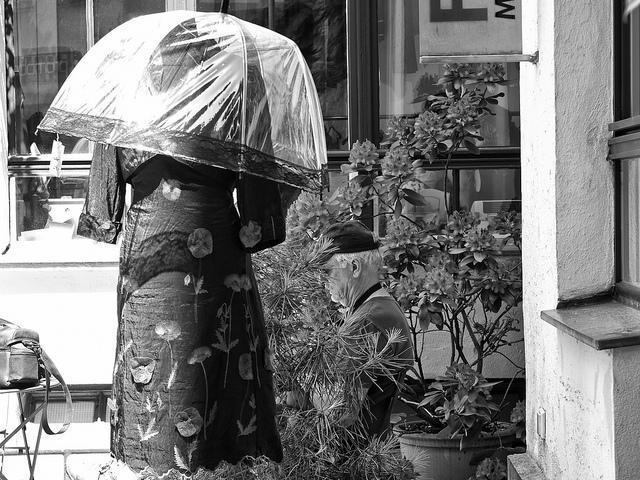Is the given caption "The potted plant is at the right side of the umbrella." fitting for the image?
Answer yes or no. Yes. 